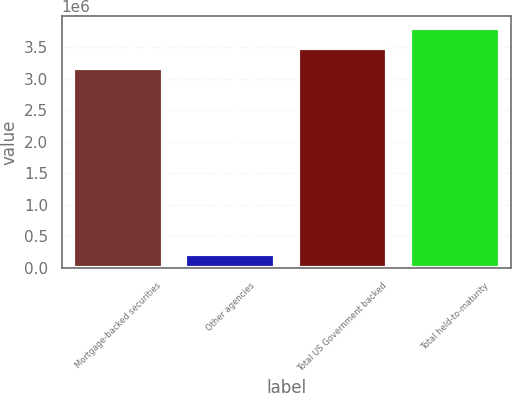Convert chart to OTSL. <chart><loc_0><loc_0><loc_500><loc_500><bar_chart><fcel>Mortgage-backed securities<fcel>Other agencies<fcel>Total US Government backed<fcel>Total held-to-maturity<nl><fcel>3.16446e+06<fcel>210664<fcel>3.48166e+06<fcel>3.79887e+06<nl></chart> 